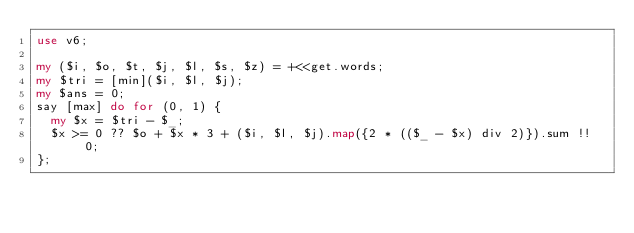<code> <loc_0><loc_0><loc_500><loc_500><_Perl_>use v6;

my ($i, $o, $t, $j, $l, $s, $z) = +<<get.words;
my $tri = [min]($i, $l, $j);
my $ans = 0;
say [max] do for (0, 1) {
  my $x = $tri - $_;
  $x >= 0 ?? $o + $x * 3 + ($i, $l, $j).map({2 * (($_ - $x) div 2)}).sum !! 0;
};
</code> 